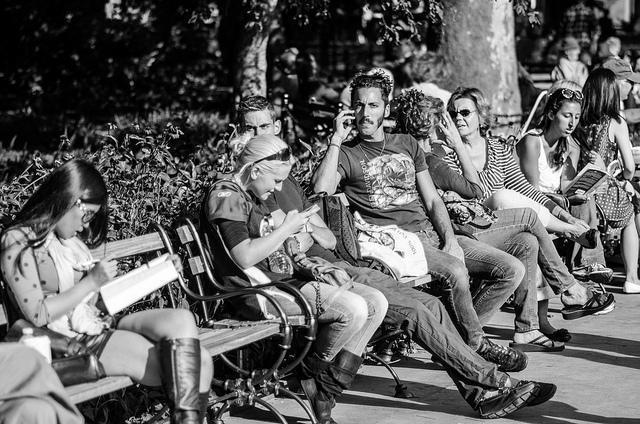What are they all doing?
Make your selection and explain in format: 'Answer: answer
Rationale: rationale.'
Options: Resting, relaxing, sleeping, eating. Answer: relaxing.
Rationale: They are resting. 